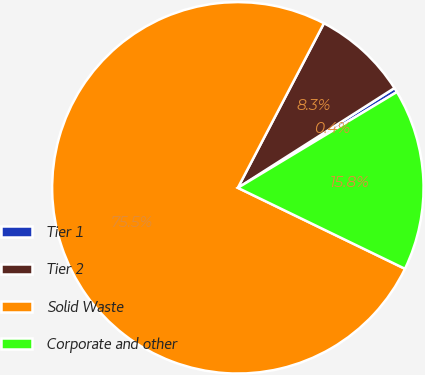Convert chart. <chart><loc_0><loc_0><loc_500><loc_500><pie_chart><fcel>Tier 1<fcel>Tier 2<fcel>Solid Waste<fcel>Corporate and other<nl><fcel>0.4%<fcel>8.3%<fcel>75.49%<fcel>15.81%<nl></chart> 